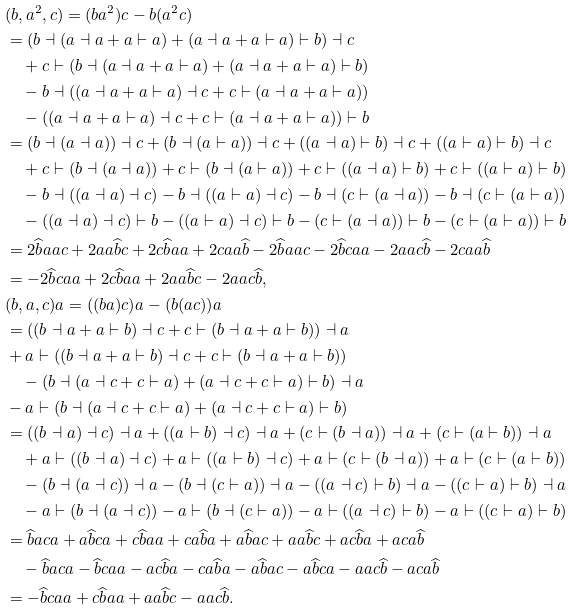Convert formula to latex. <formula><loc_0><loc_0><loc_500><loc_500>& ( b , a ^ { 2 } , c ) = ( b a ^ { 2 } ) c - b ( a ^ { 2 } c ) \\ & = ( b \dashv ( a \dashv a + a \vdash a ) + ( a \dashv a + a \vdash a ) \vdash b ) \dashv c \\ & \quad + c \vdash ( b \dashv ( a \dashv a + a \vdash a ) + ( a \dashv a + a \vdash a ) \vdash b ) \\ & \quad - b \dashv ( ( a \dashv a + a \vdash a ) \dashv c + c \vdash ( a \dashv a + a \vdash a ) ) \\ & \quad - ( ( a \dashv a + a \vdash a ) \dashv c + c \vdash ( a \dashv a + a \vdash a ) ) \vdash b \\ & = ( b \dashv ( a \dashv a ) ) \dashv c + ( b \dashv ( a \vdash a ) ) \dashv c + ( ( a \dashv a ) \vdash b ) \dashv c + ( ( a \vdash a ) \vdash b ) \dashv c \\ & \quad + c \vdash ( b \dashv ( a \dashv a ) ) + c \vdash ( b \dashv ( a \vdash a ) ) + c \vdash ( ( a \dashv a ) \vdash b ) + c \vdash ( ( a \vdash a ) \vdash b ) \\ & \quad - b \dashv ( ( a \dashv a ) \dashv c ) - b \dashv ( ( a \vdash a ) \dashv c ) - b \dashv ( c \vdash ( a \dashv a ) ) - b \dashv ( c \vdash ( a \vdash a ) ) \\ & \quad - ( ( a \dashv a ) \dashv c ) \vdash b - ( ( a \vdash a ) \dashv c ) \vdash b - ( c \vdash ( a \dashv a ) ) \vdash b - ( c \vdash ( a \vdash a ) ) \vdash b \\ & = 2 \widehat { b } a a c + 2 a a \widehat { b } c + 2 c \widehat { b } a a + 2 c a a \widehat { b } - 2 \widehat { b } a a c - 2 \widehat { b } c a a - 2 a a c \widehat { b } - 2 c a a \widehat { b } \\ & = - 2 \widehat { b } c a a + 2 c \widehat { b } a a + 2 a a \widehat { b } c - 2 a a c \widehat { b } , \\ & ( b , a , c ) a = ( ( b a ) c ) a - ( b ( a c ) ) a \\ & = ( ( b \dashv a + a \vdash b ) \dashv c + c \vdash ( b \dashv a + a \vdash b ) ) \dashv a \\ & + a \vdash ( ( b \dashv a + a \vdash b ) \dashv c + c \vdash ( b \dashv a + a \vdash b ) ) \\ & \quad - ( b \dashv ( a \dashv c + c \vdash a ) + ( a \dashv c + c \vdash a ) \vdash b ) \dashv a \\ & - a \vdash ( b \dashv ( a \dashv c + c \vdash a ) + ( a \dashv c + c \vdash a ) \vdash b ) \\ & = ( ( b \dashv a ) \dashv c ) \dashv a + ( ( a \vdash b ) \dashv c ) \dashv a + ( c \vdash ( b \dashv a ) ) \dashv a + ( c \vdash ( a \vdash b ) ) \dashv a \\ & \quad + a \vdash ( ( b \dashv a ) \dashv c ) + a \vdash ( ( a \vdash b ) \dashv c ) + a \vdash ( c \vdash ( b \dashv a ) ) + a \vdash ( c \vdash ( a \vdash b ) ) \\ & \quad - ( b \dashv ( a \dashv c ) ) \dashv a - ( b \dashv ( c \vdash a ) ) \dashv a - ( ( a \dashv c ) \vdash b ) \dashv a - ( ( c \vdash a ) \vdash b ) \dashv a \\ & \quad - a \vdash ( b \dashv ( a \dashv c ) ) - a \vdash ( b \dashv ( c \vdash a ) ) - a \vdash ( ( a \dashv c ) \vdash b ) - a \vdash ( ( c \vdash a ) \vdash b ) \\ & = \widehat { b } a c a + a \widehat { b } c a + c \widehat { b } a a + c a \widehat { b } a + a \widehat { b } a c + a a \widehat { b } c + a c \widehat { b } a + a c a \widehat { b } \\ & \quad - \widehat { b } a c a - \widehat { b } c a a - a c \widehat { b } a - c a \widehat { b } a - a \widehat { b } a c - a \widehat { b } c a - a a c \widehat { b } - a c a \widehat { b } \\ & = - \widehat { b } c a a + c \widehat { b } a a + a a \widehat { b } c - a a c \widehat { b } .</formula> 